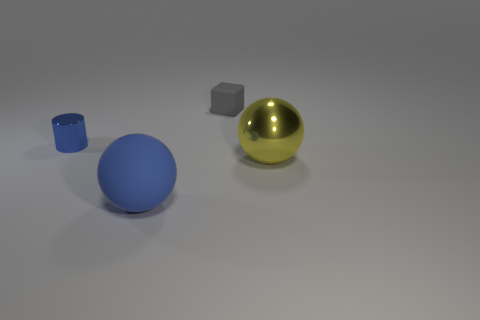What is the color of the tiny cylinder that is the same material as the yellow thing?
Your answer should be compact. Blue. What number of rubber things are right of the matte thing behind the metallic sphere?
Offer a very short reply. 0. What material is the thing that is on the right side of the small shiny thing and to the left of the block?
Ensure brevity in your answer.  Rubber. Is the shape of the shiny thing that is on the right side of the tiny matte block the same as  the tiny gray object?
Provide a short and direct response. No. Are there fewer yellow metal spheres than tiny purple rubber spheres?
Offer a very short reply. No. How many large spheres are the same color as the large metal object?
Provide a succinct answer. 0. There is a large object that is the same color as the small cylinder; what is it made of?
Your answer should be very brief. Rubber. There is a tiny matte block; does it have the same color as the tiny object to the left of the gray thing?
Give a very brief answer. No. Is the number of big blue things greater than the number of small blue spheres?
Provide a short and direct response. Yes. What is the size of the other object that is the same shape as the blue matte object?
Offer a very short reply. Large. 